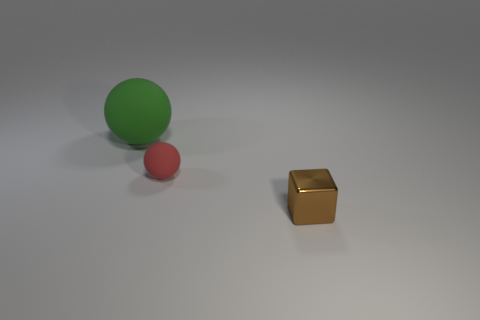Add 1 tiny red rubber spheres. How many objects exist? 4 Subtract all balls. How many objects are left? 1 Subtract 0 red cylinders. How many objects are left? 3 Subtract all purple matte balls. Subtract all matte balls. How many objects are left? 1 Add 2 big things. How many big things are left? 3 Add 3 large green spheres. How many large green spheres exist? 4 